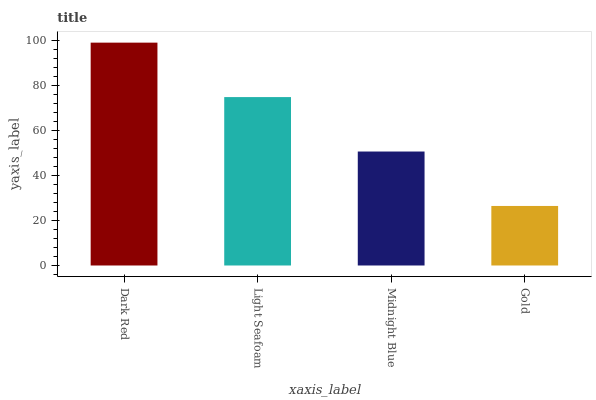Is Gold the minimum?
Answer yes or no. Yes. Is Dark Red the maximum?
Answer yes or no. Yes. Is Light Seafoam the minimum?
Answer yes or no. No. Is Light Seafoam the maximum?
Answer yes or no. No. Is Dark Red greater than Light Seafoam?
Answer yes or no. Yes. Is Light Seafoam less than Dark Red?
Answer yes or no. Yes. Is Light Seafoam greater than Dark Red?
Answer yes or no. No. Is Dark Red less than Light Seafoam?
Answer yes or no. No. Is Light Seafoam the high median?
Answer yes or no. Yes. Is Midnight Blue the low median?
Answer yes or no. Yes. Is Dark Red the high median?
Answer yes or no. No. Is Dark Red the low median?
Answer yes or no. No. 